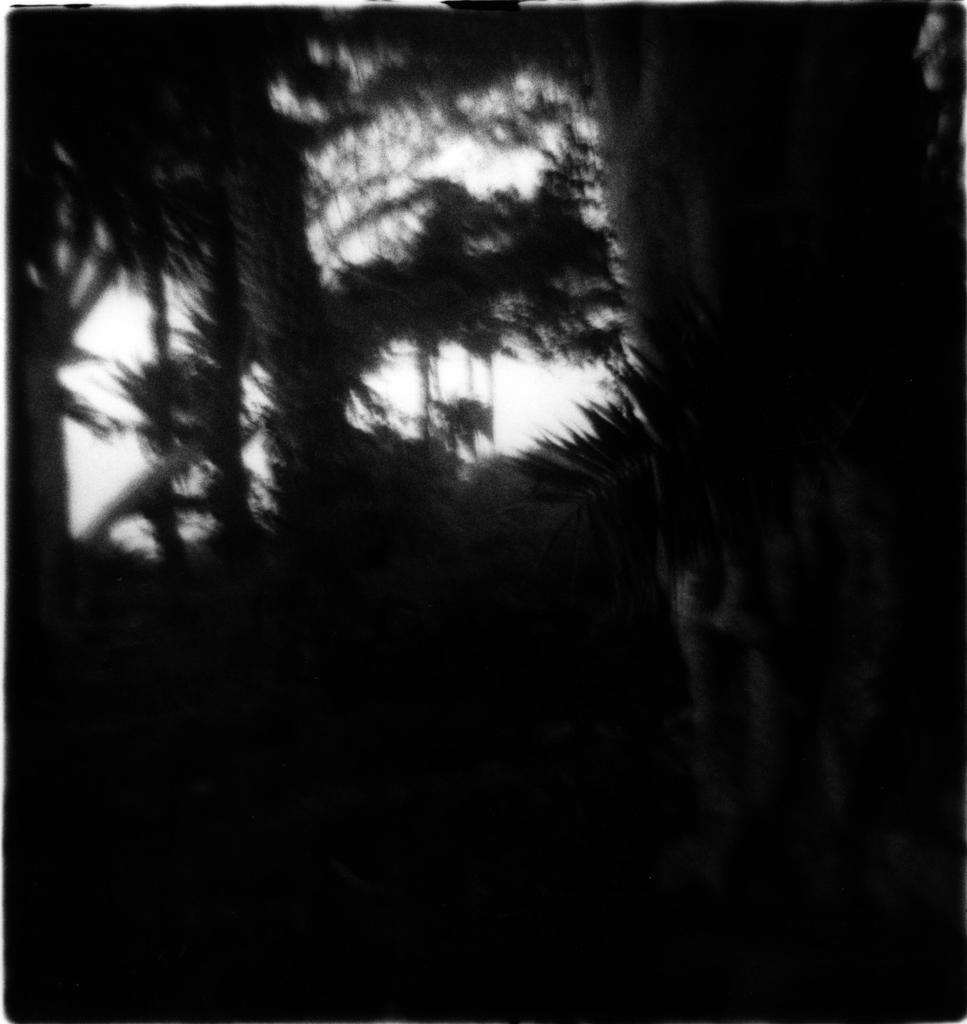Describe this image in one or two sentences. This is a black and white image. In this image we can see trees. 